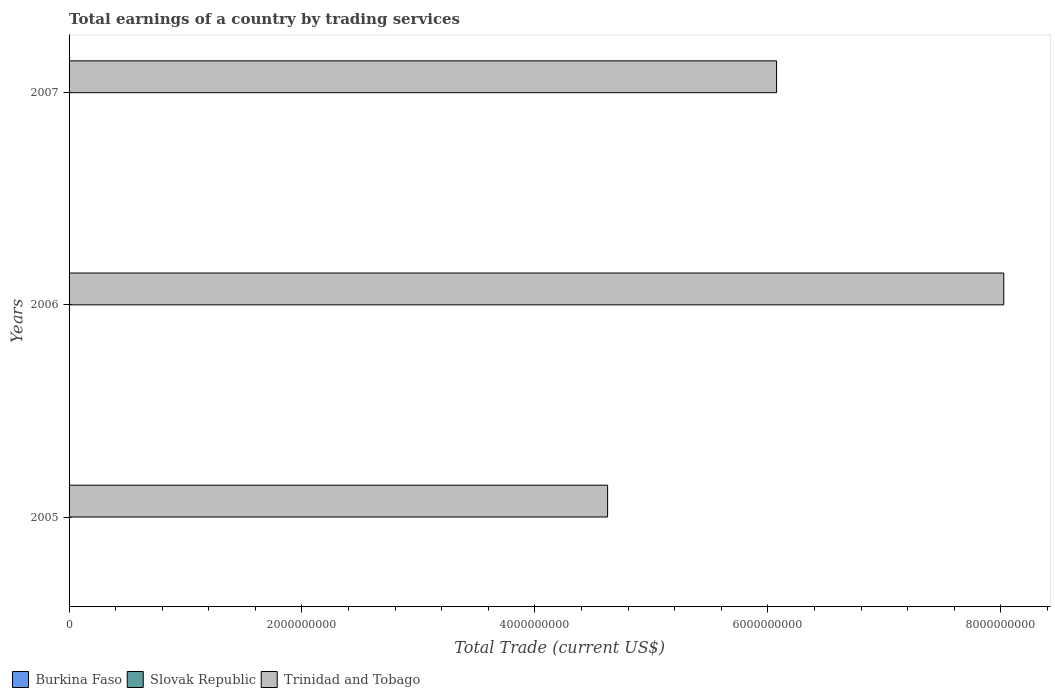Are the number of bars per tick equal to the number of legend labels?
Your answer should be very brief. No. How many bars are there on the 2nd tick from the bottom?
Offer a terse response. 1. What is the total earnings in Trinidad and Tobago in 2005?
Offer a very short reply. 4.62e+09. Across all years, what is the maximum total earnings in Trinidad and Tobago?
Provide a short and direct response. 8.03e+09. Across all years, what is the minimum total earnings in Trinidad and Tobago?
Your answer should be very brief. 4.62e+09. In which year was the total earnings in Trinidad and Tobago maximum?
Offer a very short reply. 2006. What is the total total earnings in Burkina Faso in the graph?
Offer a terse response. 0. What is the difference between the total earnings in Trinidad and Tobago in 2005 and that in 2007?
Provide a succinct answer. -1.45e+09. What is the difference between the total earnings in Slovak Republic in 2006 and the total earnings in Trinidad and Tobago in 2005?
Keep it short and to the point. -4.62e+09. What is the average total earnings in Trinidad and Tobago per year?
Make the answer very short. 6.24e+09. In how many years, is the total earnings in Burkina Faso greater than 3200000000 US$?
Offer a terse response. 0. What is the ratio of the total earnings in Trinidad and Tobago in 2006 to that in 2007?
Your answer should be very brief. 1.32. What is the difference between the highest and the second highest total earnings in Trinidad and Tobago?
Provide a short and direct response. 1.95e+09. What is the difference between the highest and the lowest total earnings in Trinidad and Tobago?
Offer a very short reply. 3.40e+09. In how many years, is the total earnings in Burkina Faso greater than the average total earnings in Burkina Faso taken over all years?
Keep it short and to the point. 0. How many bars are there?
Ensure brevity in your answer.  3. Are all the bars in the graph horizontal?
Your answer should be very brief. Yes. What is the difference between two consecutive major ticks on the X-axis?
Give a very brief answer. 2.00e+09. Does the graph contain any zero values?
Provide a succinct answer. Yes. Does the graph contain grids?
Your response must be concise. No. How many legend labels are there?
Offer a terse response. 3. How are the legend labels stacked?
Keep it short and to the point. Horizontal. What is the title of the graph?
Provide a succinct answer. Total earnings of a country by trading services. What is the label or title of the X-axis?
Ensure brevity in your answer.  Total Trade (current US$). What is the label or title of the Y-axis?
Keep it short and to the point. Years. What is the Total Trade (current US$) of Trinidad and Tobago in 2005?
Make the answer very short. 4.62e+09. What is the Total Trade (current US$) of Slovak Republic in 2006?
Offer a very short reply. 0. What is the Total Trade (current US$) in Trinidad and Tobago in 2006?
Your answer should be compact. 8.03e+09. What is the Total Trade (current US$) of Slovak Republic in 2007?
Offer a very short reply. 0. What is the Total Trade (current US$) in Trinidad and Tobago in 2007?
Provide a short and direct response. 6.08e+09. Across all years, what is the maximum Total Trade (current US$) in Trinidad and Tobago?
Your answer should be compact. 8.03e+09. Across all years, what is the minimum Total Trade (current US$) of Trinidad and Tobago?
Provide a short and direct response. 4.62e+09. What is the total Total Trade (current US$) of Burkina Faso in the graph?
Offer a very short reply. 0. What is the total Total Trade (current US$) in Slovak Republic in the graph?
Your answer should be very brief. 0. What is the total Total Trade (current US$) in Trinidad and Tobago in the graph?
Ensure brevity in your answer.  1.87e+1. What is the difference between the Total Trade (current US$) in Trinidad and Tobago in 2005 and that in 2006?
Your answer should be very brief. -3.40e+09. What is the difference between the Total Trade (current US$) in Trinidad and Tobago in 2005 and that in 2007?
Offer a terse response. -1.45e+09. What is the difference between the Total Trade (current US$) in Trinidad and Tobago in 2006 and that in 2007?
Offer a very short reply. 1.95e+09. What is the average Total Trade (current US$) of Slovak Republic per year?
Your answer should be compact. 0. What is the average Total Trade (current US$) in Trinidad and Tobago per year?
Your response must be concise. 6.24e+09. What is the ratio of the Total Trade (current US$) of Trinidad and Tobago in 2005 to that in 2006?
Offer a very short reply. 0.58. What is the ratio of the Total Trade (current US$) of Trinidad and Tobago in 2005 to that in 2007?
Give a very brief answer. 0.76. What is the ratio of the Total Trade (current US$) of Trinidad and Tobago in 2006 to that in 2007?
Your response must be concise. 1.32. What is the difference between the highest and the second highest Total Trade (current US$) in Trinidad and Tobago?
Your answer should be very brief. 1.95e+09. What is the difference between the highest and the lowest Total Trade (current US$) in Trinidad and Tobago?
Offer a very short reply. 3.40e+09. 